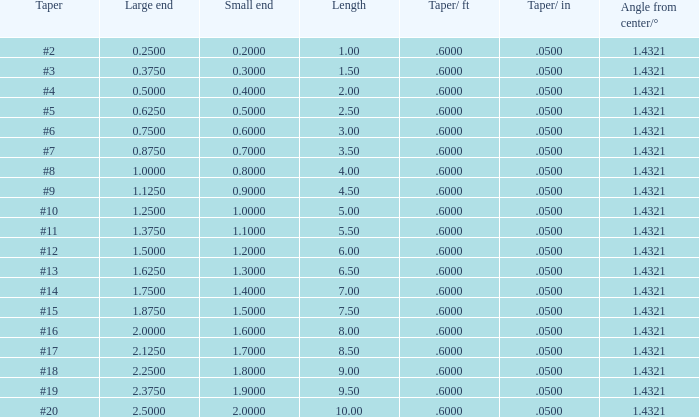Which Large end has a Taper/ft smaller than 0.6000000000000001? 19.0. 